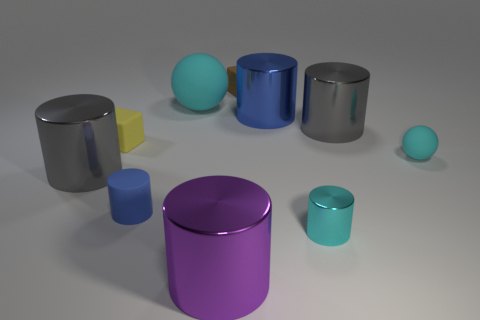Subtract all blue spheres. How many gray cylinders are left? 2 Subtract all gray cylinders. How many cylinders are left? 4 Subtract all blue cylinders. How many cylinders are left? 4 Subtract 2 cylinders. How many cylinders are left? 4 Subtract all blue cylinders. Subtract all gray blocks. How many cylinders are left? 4 Subtract all blue cylinders. Subtract all big cyan spheres. How many objects are left? 7 Add 7 big purple cylinders. How many big purple cylinders are left? 8 Add 4 small cyan matte balls. How many small cyan matte balls exist? 5 Subtract 2 cyan spheres. How many objects are left? 8 Subtract all balls. How many objects are left? 8 